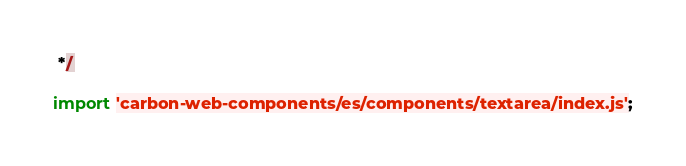<code> <loc_0><loc_0><loc_500><loc_500><_JavaScript_> */

import 'carbon-web-components/es/components/textarea/index.js';
</code> 